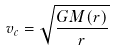<formula> <loc_0><loc_0><loc_500><loc_500>v _ { c } = \sqrt { \frac { G M ( r ) } { r } }</formula> 